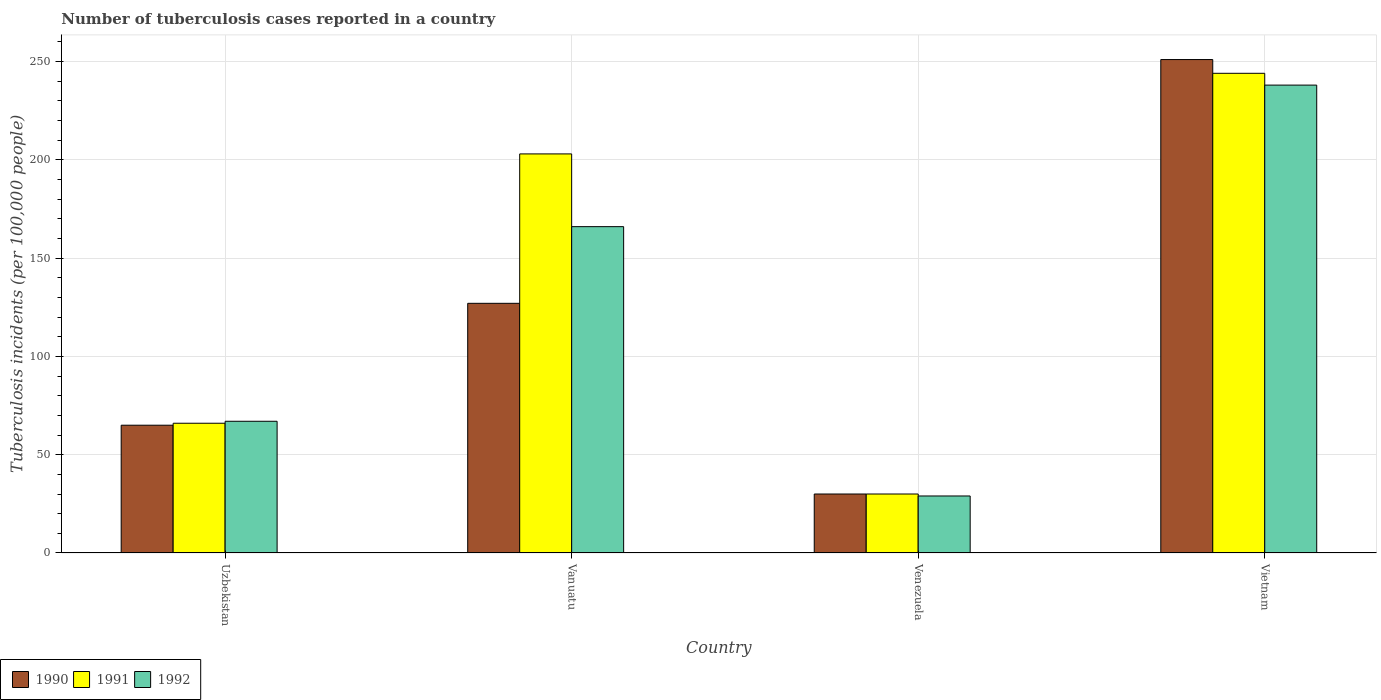Are the number of bars per tick equal to the number of legend labels?
Your answer should be compact. Yes. How many bars are there on the 3rd tick from the right?
Offer a very short reply. 3. What is the label of the 2nd group of bars from the left?
Provide a short and direct response. Vanuatu. In how many cases, is the number of bars for a given country not equal to the number of legend labels?
Give a very brief answer. 0. What is the number of tuberculosis cases reported in in 1991 in Vietnam?
Keep it short and to the point. 244. Across all countries, what is the maximum number of tuberculosis cases reported in in 1991?
Ensure brevity in your answer.  244. In which country was the number of tuberculosis cases reported in in 1991 maximum?
Offer a terse response. Vietnam. In which country was the number of tuberculosis cases reported in in 1990 minimum?
Your answer should be compact. Venezuela. What is the total number of tuberculosis cases reported in in 1990 in the graph?
Your response must be concise. 473. What is the difference between the number of tuberculosis cases reported in in 1992 in Uzbekistan and that in Vanuatu?
Your answer should be compact. -99. What is the difference between the number of tuberculosis cases reported in in 1991 in Vietnam and the number of tuberculosis cases reported in in 1990 in Venezuela?
Offer a terse response. 214. What is the average number of tuberculosis cases reported in in 1990 per country?
Your answer should be very brief. 118.25. What is the difference between the number of tuberculosis cases reported in of/in 1990 and number of tuberculosis cases reported in of/in 1992 in Uzbekistan?
Your response must be concise. -2. In how many countries, is the number of tuberculosis cases reported in in 1990 greater than 30?
Ensure brevity in your answer.  3. What is the ratio of the number of tuberculosis cases reported in in 1990 in Uzbekistan to that in Vietnam?
Make the answer very short. 0.26. Is the number of tuberculosis cases reported in in 1990 in Uzbekistan less than that in Vietnam?
Your answer should be compact. Yes. Is the difference between the number of tuberculosis cases reported in in 1990 in Uzbekistan and Venezuela greater than the difference between the number of tuberculosis cases reported in in 1992 in Uzbekistan and Venezuela?
Make the answer very short. No. What is the difference between the highest and the second highest number of tuberculosis cases reported in in 1992?
Keep it short and to the point. -99. What is the difference between the highest and the lowest number of tuberculosis cases reported in in 1990?
Make the answer very short. 221. What does the 1st bar from the left in Vietnam represents?
Your answer should be compact. 1990. How many bars are there?
Offer a very short reply. 12. Are all the bars in the graph horizontal?
Make the answer very short. No. What is the difference between two consecutive major ticks on the Y-axis?
Your response must be concise. 50. Are the values on the major ticks of Y-axis written in scientific E-notation?
Your answer should be very brief. No. Does the graph contain any zero values?
Offer a very short reply. No. How many legend labels are there?
Ensure brevity in your answer.  3. How are the legend labels stacked?
Offer a very short reply. Horizontal. What is the title of the graph?
Provide a succinct answer. Number of tuberculosis cases reported in a country. Does "2009" appear as one of the legend labels in the graph?
Make the answer very short. No. What is the label or title of the X-axis?
Offer a terse response. Country. What is the label or title of the Y-axis?
Your answer should be compact. Tuberculosis incidents (per 100,0 people). What is the Tuberculosis incidents (per 100,000 people) in 1990 in Uzbekistan?
Your answer should be very brief. 65. What is the Tuberculosis incidents (per 100,000 people) of 1992 in Uzbekistan?
Keep it short and to the point. 67. What is the Tuberculosis incidents (per 100,000 people) of 1990 in Vanuatu?
Provide a short and direct response. 127. What is the Tuberculosis incidents (per 100,000 people) of 1991 in Vanuatu?
Your response must be concise. 203. What is the Tuberculosis incidents (per 100,000 people) of 1992 in Vanuatu?
Offer a very short reply. 166. What is the Tuberculosis incidents (per 100,000 people) of 1992 in Venezuela?
Provide a succinct answer. 29. What is the Tuberculosis incidents (per 100,000 people) of 1990 in Vietnam?
Your answer should be very brief. 251. What is the Tuberculosis incidents (per 100,000 people) in 1991 in Vietnam?
Provide a succinct answer. 244. What is the Tuberculosis incidents (per 100,000 people) of 1992 in Vietnam?
Provide a succinct answer. 238. Across all countries, what is the maximum Tuberculosis incidents (per 100,000 people) in 1990?
Ensure brevity in your answer.  251. Across all countries, what is the maximum Tuberculosis incidents (per 100,000 people) of 1991?
Offer a terse response. 244. Across all countries, what is the maximum Tuberculosis incidents (per 100,000 people) in 1992?
Keep it short and to the point. 238. Across all countries, what is the minimum Tuberculosis incidents (per 100,000 people) of 1992?
Provide a short and direct response. 29. What is the total Tuberculosis incidents (per 100,000 people) in 1990 in the graph?
Make the answer very short. 473. What is the total Tuberculosis incidents (per 100,000 people) of 1991 in the graph?
Give a very brief answer. 543. What is the total Tuberculosis incidents (per 100,000 people) in 1992 in the graph?
Keep it short and to the point. 500. What is the difference between the Tuberculosis incidents (per 100,000 people) of 1990 in Uzbekistan and that in Vanuatu?
Give a very brief answer. -62. What is the difference between the Tuberculosis incidents (per 100,000 people) in 1991 in Uzbekistan and that in Vanuatu?
Provide a succinct answer. -137. What is the difference between the Tuberculosis incidents (per 100,000 people) in 1992 in Uzbekistan and that in Vanuatu?
Your answer should be very brief. -99. What is the difference between the Tuberculosis incidents (per 100,000 people) of 1990 in Uzbekistan and that in Vietnam?
Give a very brief answer. -186. What is the difference between the Tuberculosis incidents (per 100,000 people) in 1991 in Uzbekistan and that in Vietnam?
Keep it short and to the point. -178. What is the difference between the Tuberculosis incidents (per 100,000 people) in 1992 in Uzbekistan and that in Vietnam?
Provide a succinct answer. -171. What is the difference between the Tuberculosis incidents (per 100,000 people) in 1990 in Vanuatu and that in Venezuela?
Offer a terse response. 97. What is the difference between the Tuberculosis incidents (per 100,000 people) of 1991 in Vanuatu and that in Venezuela?
Keep it short and to the point. 173. What is the difference between the Tuberculosis incidents (per 100,000 people) in 1992 in Vanuatu and that in Venezuela?
Your answer should be compact. 137. What is the difference between the Tuberculosis incidents (per 100,000 people) in 1990 in Vanuatu and that in Vietnam?
Provide a short and direct response. -124. What is the difference between the Tuberculosis incidents (per 100,000 people) in 1991 in Vanuatu and that in Vietnam?
Offer a very short reply. -41. What is the difference between the Tuberculosis incidents (per 100,000 people) in 1992 in Vanuatu and that in Vietnam?
Ensure brevity in your answer.  -72. What is the difference between the Tuberculosis incidents (per 100,000 people) of 1990 in Venezuela and that in Vietnam?
Your response must be concise. -221. What is the difference between the Tuberculosis incidents (per 100,000 people) in 1991 in Venezuela and that in Vietnam?
Provide a succinct answer. -214. What is the difference between the Tuberculosis incidents (per 100,000 people) of 1992 in Venezuela and that in Vietnam?
Ensure brevity in your answer.  -209. What is the difference between the Tuberculosis incidents (per 100,000 people) in 1990 in Uzbekistan and the Tuberculosis incidents (per 100,000 people) in 1991 in Vanuatu?
Provide a succinct answer. -138. What is the difference between the Tuberculosis incidents (per 100,000 people) in 1990 in Uzbekistan and the Tuberculosis incidents (per 100,000 people) in 1992 in Vanuatu?
Your answer should be compact. -101. What is the difference between the Tuberculosis incidents (per 100,000 people) in 1991 in Uzbekistan and the Tuberculosis incidents (per 100,000 people) in 1992 in Vanuatu?
Your answer should be very brief. -100. What is the difference between the Tuberculosis incidents (per 100,000 people) in 1990 in Uzbekistan and the Tuberculosis incidents (per 100,000 people) in 1991 in Venezuela?
Make the answer very short. 35. What is the difference between the Tuberculosis incidents (per 100,000 people) in 1990 in Uzbekistan and the Tuberculosis incidents (per 100,000 people) in 1991 in Vietnam?
Ensure brevity in your answer.  -179. What is the difference between the Tuberculosis incidents (per 100,000 people) of 1990 in Uzbekistan and the Tuberculosis incidents (per 100,000 people) of 1992 in Vietnam?
Ensure brevity in your answer.  -173. What is the difference between the Tuberculosis incidents (per 100,000 people) in 1991 in Uzbekistan and the Tuberculosis incidents (per 100,000 people) in 1992 in Vietnam?
Provide a succinct answer. -172. What is the difference between the Tuberculosis incidents (per 100,000 people) of 1990 in Vanuatu and the Tuberculosis incidents (per 100,000 people) of 1991 in Venezuela?
Your answer should be compact. 97. What is the difference between the Tuberculosis incidents (per 100,000 people) of 1991 in Vanuatu and the Tuberculosis incidents (per 100,000 people) of 1992 in Venezuela?
Your response must be concise. 174. What is the difference between the Tuberculosis incidents (per 100,000 people) of 1990 in Vanuatu and the Tuberculosis incidents (per 100,000 people) of 1991 in Vietnam?
Your answer should be very brief. -117. What is the difference between the Tuberculosis incidents (per 100,000 people) in 1990 in Vanuatu and the Tuberculosis incidents (per 100,000 people) in 1992 in Vietnam?
Give a very brief answer. -111. What is the difference between the Tuberculosis incidents (per 100,000 people) in 1991 in Vanuatu and the Tuberculosis incidents (per 100,000 people) in 1992 in Vietnam?
Offer a terse response. -35. What is the difference between the Tuberculosis incidents (per 100,000 people) of 1990 in Venezuela and the Tuberculosis incidents (per 100,000 people) of 1991 in Vietnam?
Offer a terse response. -214. What is the difference between the Tuberculosis incidents (per 100,000 people) in 1990 in Venezuela and the Tuberculosis incidents (per 100,000 people) in 1992 in Vietnam?
Provide a succinct answer. -208. What is the difference between the Tuberculosis incidents (per 100,000 people) in 1991 in Venezuela and the Tuberculosis incidents (per 100,000 people) in 1992 in Vietnam?
Your response must be concise. -208. What is the average Tuberculosis incidents (per 100,000 people) of 1990 per country?
Provide a succinct answer. 118.25. What is the average Tuberculosis incidents (per 100,000 people) in 1991 per country?
Give a very brief answer. 135.75. What is the average Tuberculosis incidents (per 100,000 people) in 1992 per country?
Ensure brevity in your answer.  125. What is the difference between the Tuberculosis incidents (per 100,000 people) of 1991 and Tuberculosis incidents (per 100,000 people) of 1992 in Uzbekistan?
Offer a very short reply. -1. What is the difference between the Tuberculosis incidents (per 100,000 people) of 1990 and Tuberculosis incidents (per 100,000 people) of 1991 in Vanuatu?
Offer a very short reply. -76. What is the difference between the Tuberculosis incidents (per 100,000 people) of 1990 and Tuberculosis incidents (per 100,000 people) of 1992 in Vanuatu?
Give a very brief answer. -39. What is the difference between the Tuberculosis incidents (per 100,000 people) in 1991 and Tuberculosis incidents (per 100,000 people) in 1992 in Vanuatu?
Ensure brevity in your answer.  37. What is the difference between the Tuberculosis incidents (per 100,000 people) in 1990 and Tuberculosis incidents (per 100,000 people) in 1991 in Venezuela?
Provide a short and direct response. 0. What is the difference between the Tuberculosis incidents (per 100,000 people) in 1991 and Tuberculosis incidents (per 100,000 people) in 1992 in Venezuela?
Ensure brevity in your answer.  1. What is the difference between the Tuberculosis incidents (per 100,000 people) in 1990 and Tuberculosis incidents (per 100,000 people) in 1991 in Vietnam?
Your answer should be very brief. 7. What is the difference between the Tuberculosis incidents (per 100,000 people) in 1990 and Tuberculosis incidents (per 100,000 people) in 1992 in Vietnam?
Offer a very short reply. 13. What is the difference between the Tuberculosis incidents (per 100,000 people) of 1991 and Tuberculosis incidents (per 100,000 people) of 1992 in Vietnam?
Keep it short and to the point. 6. What is the ratio of the Tuberculosis incidents (per 100,000 people) of 1990 in Uzbekistan to that in Vanuatu?
Your response must be concise. 0.51. What is the ratio of the Tuberculosis incidents (per 100,000 people) in 1991 in Uzbekistan to that in Vanuatu?
Your response must be concise. 0.33. What is the ratio of the Tuberculosis incidents (per 100,000 people) in 1992 in Uzbekistan to that in Vanuatu?
Offer a very short reply. 0.4. What is the ratio of the Tuberculosis incidents (per 100,000 people) in 1990 in Uzbekistan to that in Venezuela?
Give a very brief answer. 2.17. What is the ratio of the Tuberculosis incidents (per 100,000 people) of 1992 in Uzbekistan to that in Venezuela?
Keep it short and to the point. 2.31. What is the ratio of the Tuberculosis incidents (per 100,000 people) in 1990 in Uzbekistan to that in Vietnam?
Give a very brief answer. 0.26. What is the ratio of the Tuberculosis incidents (per 100,000 people) in 1991 in Uzbekistan to that in Vietnam?
Give a very brief answer. 0.27. What is the ratio of the Tuberculosis incidents (per 100,000 people) of 1992 in Uzbekistan to that in Vietnam?
Offer a terse response. 0.28. What is the ratio of the Tuberculosis incidents (per 100,000 people) of 1990 in Vanuatu to that in Venezuela?
Ensure brevity in your answer.  4.23. What is the ratio of the Tuberculosis incidents (per 100,000 people) in 1991 in Vanuatu to that in Venezuela?
Provide a short and direct response. 6.77. What is the ratio of the Tuberculosis incidents (per 100,000 people) in 1992 in Vanuatu to that in Venezuela?
Your answer should be very brief. 5.72. What is the ratio of the Tuberculosis incidents (per 100,000 people) of 1990 in Vanuatu to that in Vietnam?
Your answer should be compact. 0.51. What is the ratio of the Tuberculosis incidents (per 100,000 people) of 1991 in Vanuatu to that in Vietnam?
Offer a very short reply. 0.83. What is the ratio of the Tuberculosis incidents (per 100,000 people) in 1992 in Vanuatu to that in Vietnam?
Offer a very short reply. 0.7. What is the ratio of the Tuberculosis incidents (per 100,000 people) of 1990 in Venezuela to that in Vietnam?
Offer a very short reply. 0.12. What is the ratio of the Tuberculosis incidents (per 100,000 people) of 1991 in Venezuela to that in Vietnam?
Your response must be concise. 0.12. What is the ratio of the Tuberculosis incidents (per 100,000 people) of 1992 in Venezuela to that in Vietnam?
Your response must be concise. 0.12. What is the difference between the highest and the second highest Tuberculosis incidents (per 100,000 people) of 1990?
Provide a succinct answer. 124. What is the difference between the highest and the second highest Tuberculosis incidents (per 100,000 people) of 1991?
Your answer should be compact. 41. What is the difference between the highest and the lowest Tuberculosis incidents (per 100,000 people) of 1990?
Your answer should be compact. 221. What is the difference between the highest and the lowest Tuberculosis incidents (per 100,000 people) of 1991?
Offer a terse response. 214. What is the difference between the highest and the lowest Tuberculosis incidents (per 100,000 people) of 1992?
Make the answer very short. 209. 